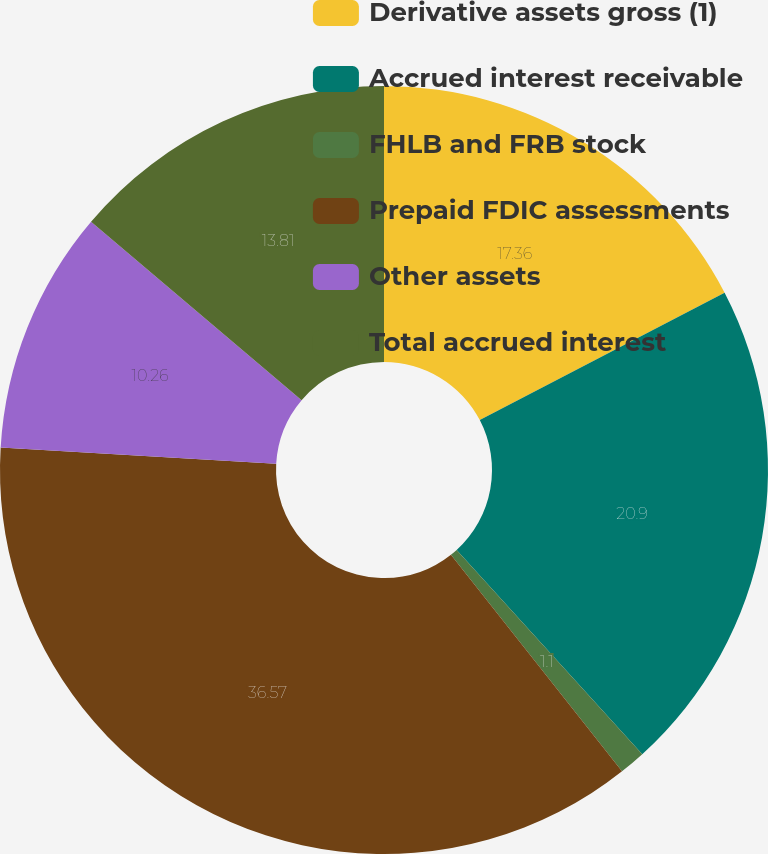<chart> <loc_0><loc_0><loc_500><loc_500><pie_chart><fcel>Derivative assets gross (1)<fcel>Accrued interest receivable<fcel>FHLB and FRB stock<fcel>Prepaid FDIC assessments<fcel>Other assets<fcel>Total accrued interest<nl><fcel>17.36%<fcel>20.9%<fcel>1.1%<fcel>36.57%<fcel>10.26%<fcel>13.81%<nl></chart> 